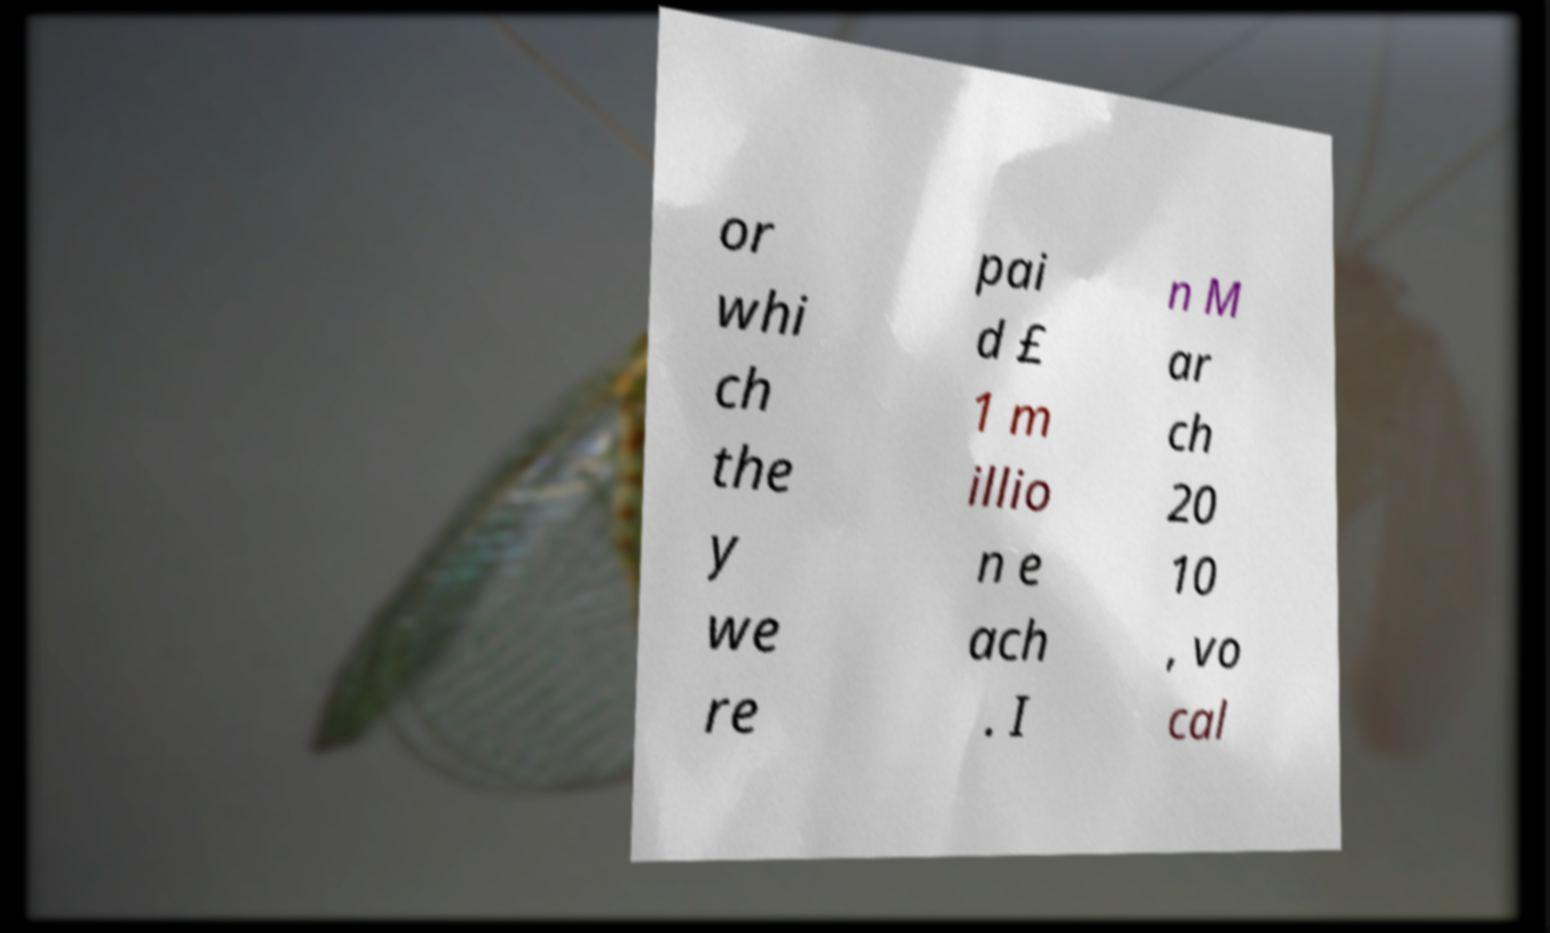Could you assist in decoding the text presented in this image and type it out clearly? or whi ch the y we re pai d £ 1 m illio n e ach . I n M ar ch 20 10 , vo cal 